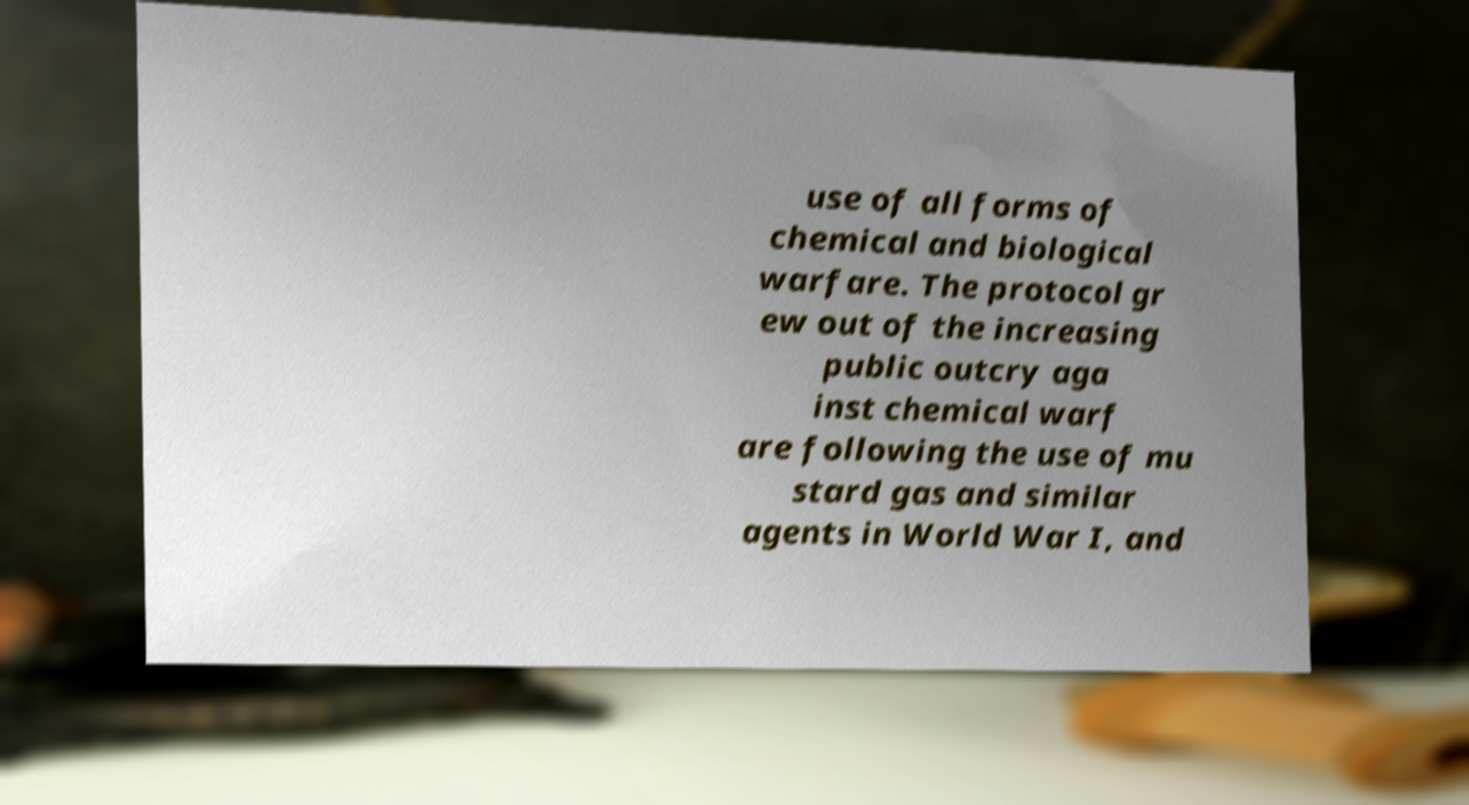Can you read and provide the text displayed in the image?This photo seems to have some interesting text. Can you extract and type it out for me? use of all forms of chemical and biological warfare. The protocol gr ew out of the increasing public outcry aga inst chemical warf are following the use of mu stard gas and similar agents in World War I, and 